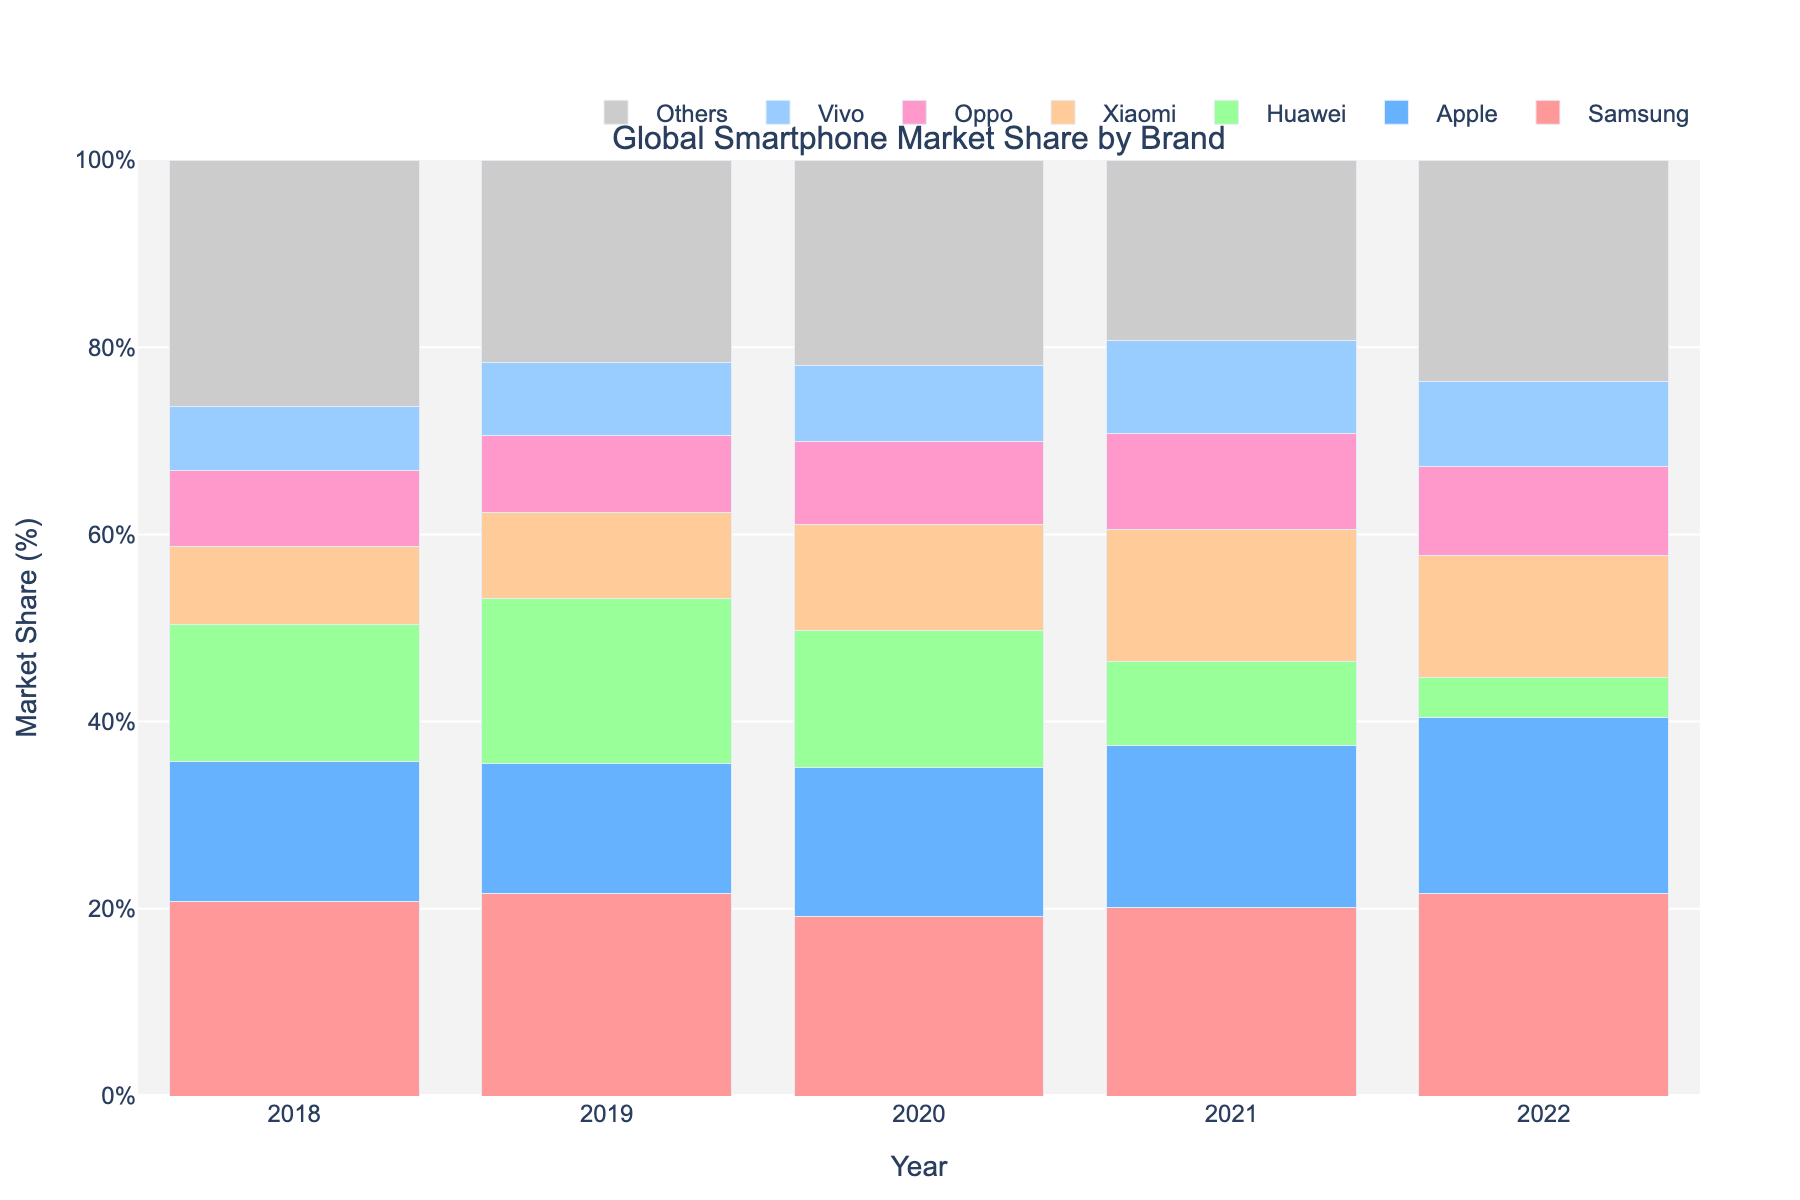What was the market share difference between Samsung and Apple in 2018? The market share of Samsung in 2018 was 20.8% and Apple was 14.9%. The difference is calculated as 20.8% - 14.9% = 5.9%.
Answer: 5.9% Which brand saw the largest increase in market share from 2018 to 2022? Huawei had a market share of 14.7% in 2018 and 4.3% in 2022. The change is 4.3% - 14.7% = -10.4%. Xiaomi had a market share of 8.3% in 2018 and 13.1% in 2022. The change is 13.1% - 8.3% = 4.8%. Apple increased by 18.8% - 14.9% = 3.9%, while Samsung, Oppo, Vivo, and Others had smaller changes. Thus, Xiaomi had the largest increase of 4.8%.
Answer: Xiaomi Which brand had the smallest market share in 2021? Looking at the bars for 2021, Huawei had the smallest market share at 8.9%.
Answer: Huawei What was the average market share of Vivo across the five years displayed? Vivo's market shares are 6.9%, 7.8%, 8.1%, 9.9%, and 9.0%. The sum is 6.9 + 7.8 + 8.1 + 9.9 + 9.0 = 41.7, and the average is 41.7 / 5 = 8.34%.
Answer: 8.34% In what year did Apple have the highest market share, and what was it? By looking at the bars representing Apple, we see the tallest one corresponds to 2022 with a market share of 18.8%.
Answer: 2022 Which two brands had nearly equal market shares in 2020? In 2020, Huawei had a market share of 14.6%, and Apple had 15.9%. The difference is quite small (15.9% - 14.6% = 1.3%). So, Apple and Huawei had nearly equal market shares in 2020.
Answer: Apple and Huawei How did the market share of 'Others' change from 2019 to 2020? In 2019, 'Others' had a market share of 21.6%. In 2020, it was 22.0%. The change is 22.0% - 21.6% = 0.4%.
Answer: 0.4% 